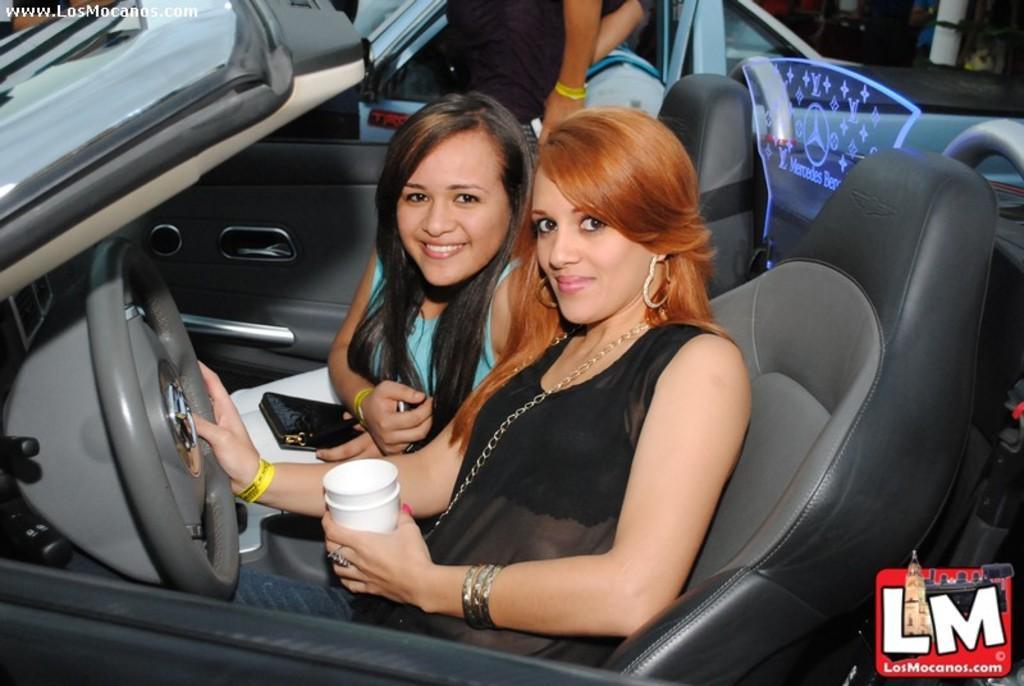Could you give a brief overview of what you see in this image? In this image there are two persons who are sitting in the car and at the foreground of the image there is a person wearing black color dress holding glass,steering in her hands and there is a person wearing blue color dress holding wallet in her hands. 